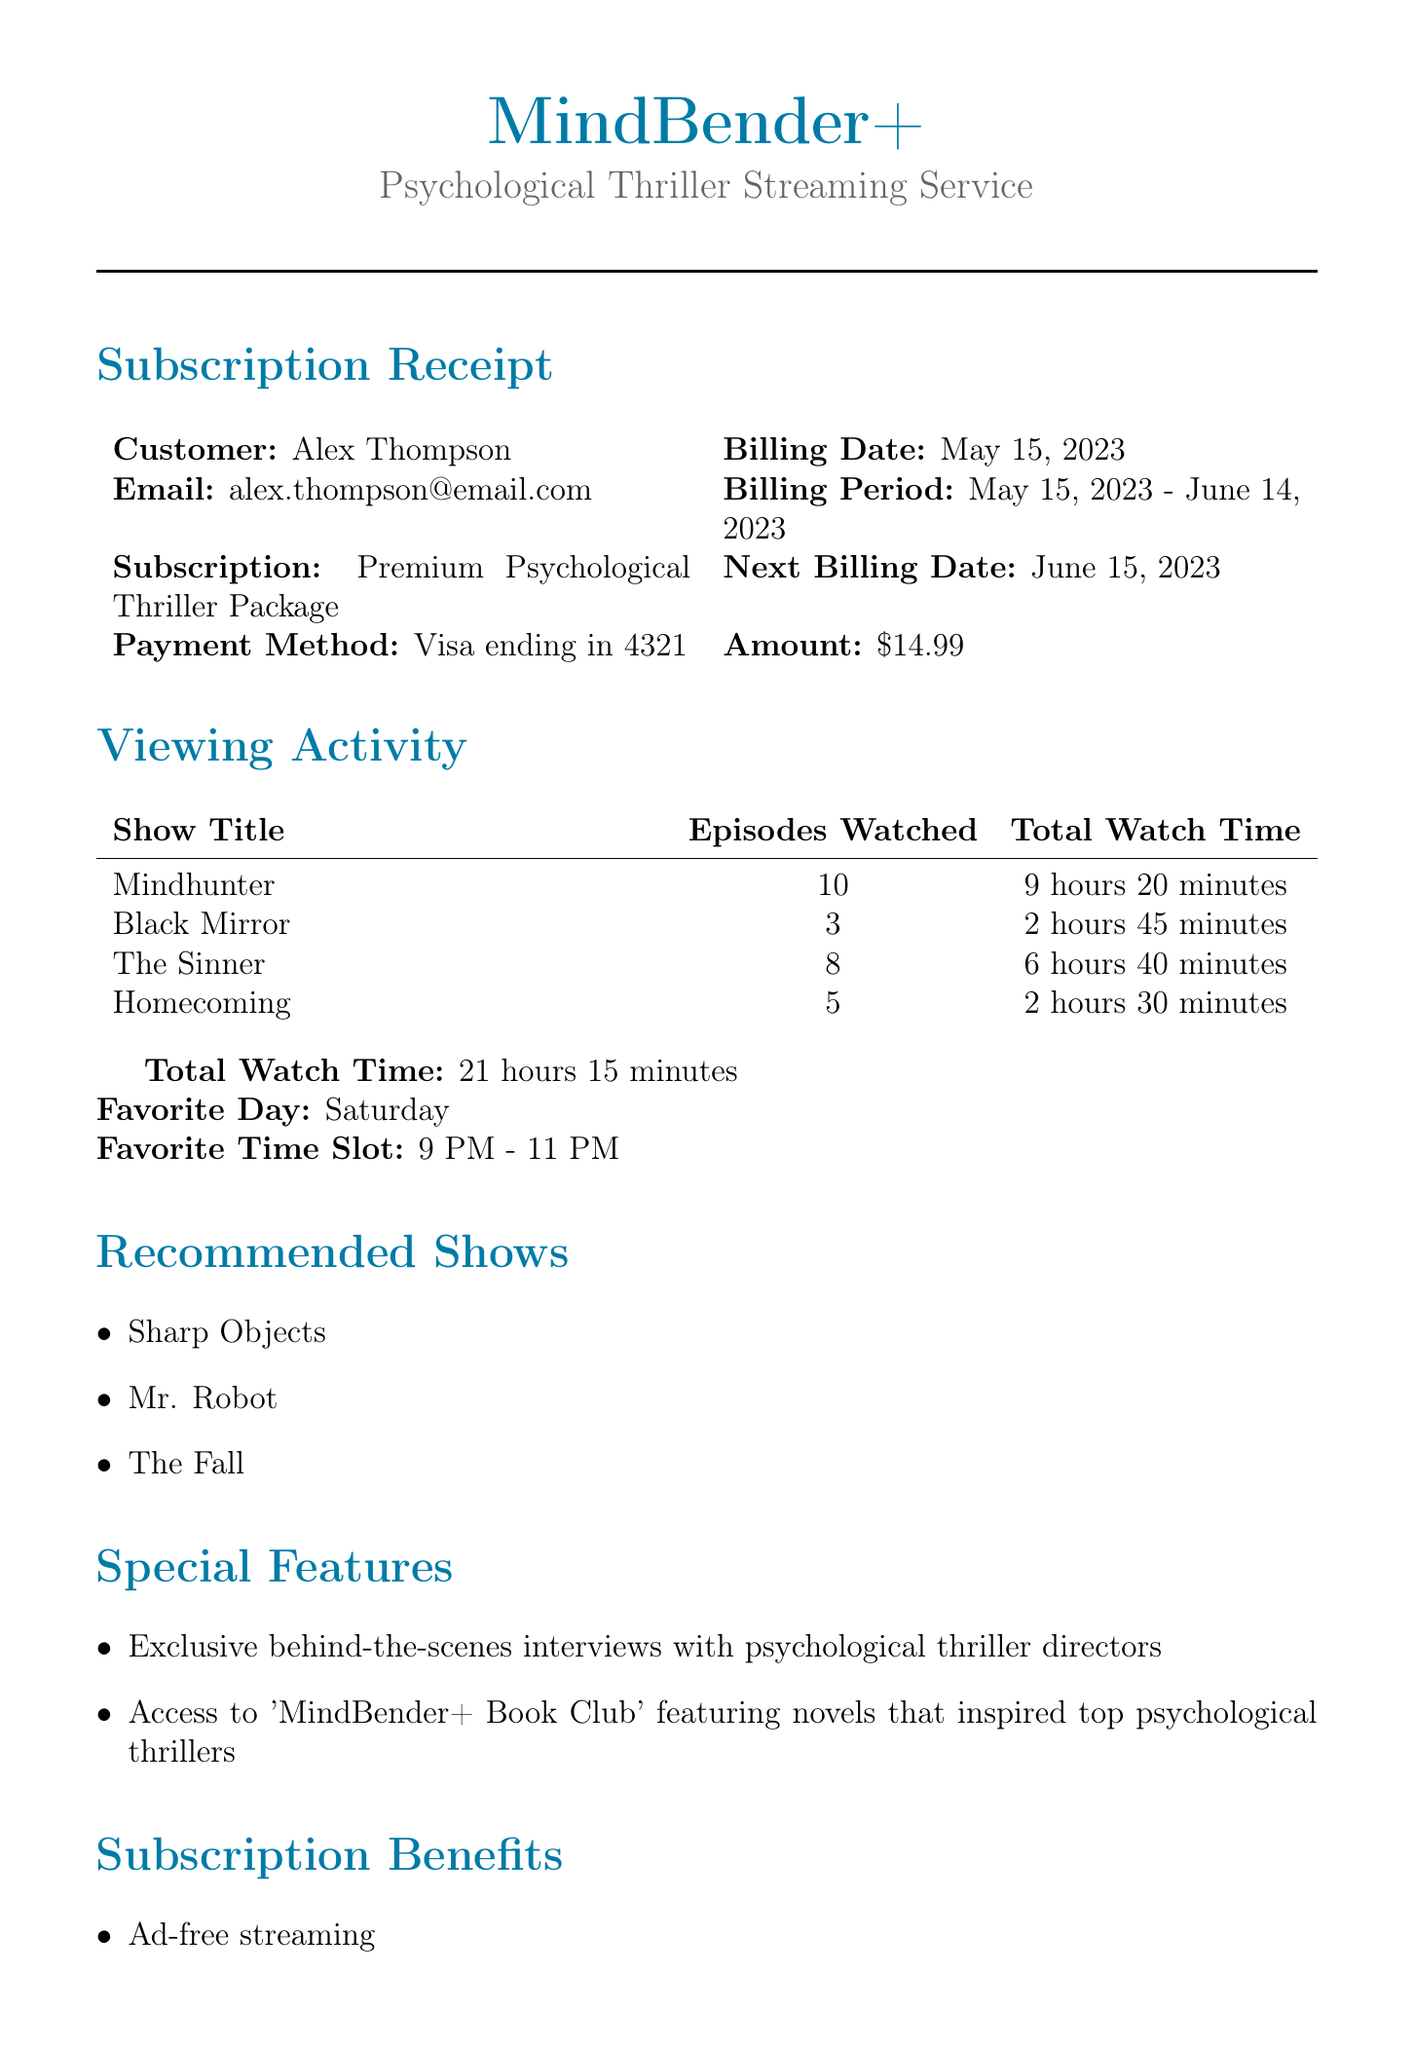What is the name of the streaming service? The document states the streaming service is MindBender+.
Answer: MindBender+ What is the subscription type? The subscription type listed is the Premium Psychological Thriller Package.
Answer: Premium Psychological Thriller Package What is the total watch time for all shows? The total watch time is calculated from the viewing activity section and is mentioned directly.
Answer: 21 hours 15 minutes How many episodes of "The Sinner" were watched? The document specifies the number of episodes watched for "The Sinner."
Answer: 8 What is the next billing date? The next billing date is provided in the document.
Answer: June 15, 2023 Which day is indicated as the favorite for watching shows? The document points out the favorite day for viewing activity.
Answer: Saturday What special feature includes interviews with directors? One of the special features noted involves exclusive behind-the-scenes interviews.
Answer: Exclusive behind-the-scenes interviews with psychological thriller directors How many episodes were watched in total for "Mindhunter"? The document lists the number of episodes watched for "Mindhunter."
Answer: 10 What payment method is used? The payment method is mentioned directly in the document.
Answer: Visa ending in 4321 Which show is recommended that has a similar theme? The recommended shows section includes a list of similar themed shows, one of which is noted.
Answer: Sharp Objects 